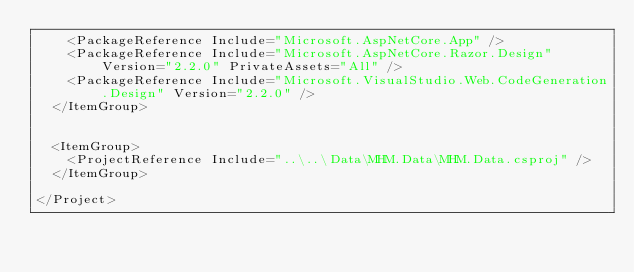Convert code to text. <code><loc_0><loc_0><loc_500><loc_500><_XML_>    <PackageReference Include="Microsoft.AspNetCore.App" />
    <PackageReference Include="Microsoft.AspNetCore.Razor.Design" Version="2.2.0" PrivateAssets="All" />
    <PackageReference Include="Microsoft.VisualStudio.Web.CodeGeneration.Design" Version="2.2.0" />
  </ItemGroup>


  <ItemGroup>
    <ProjectReference Include="..\..\Data\MHM.Data\MHM.Data.csproj" />
  </ItemGroup>

</Project>
</code> 